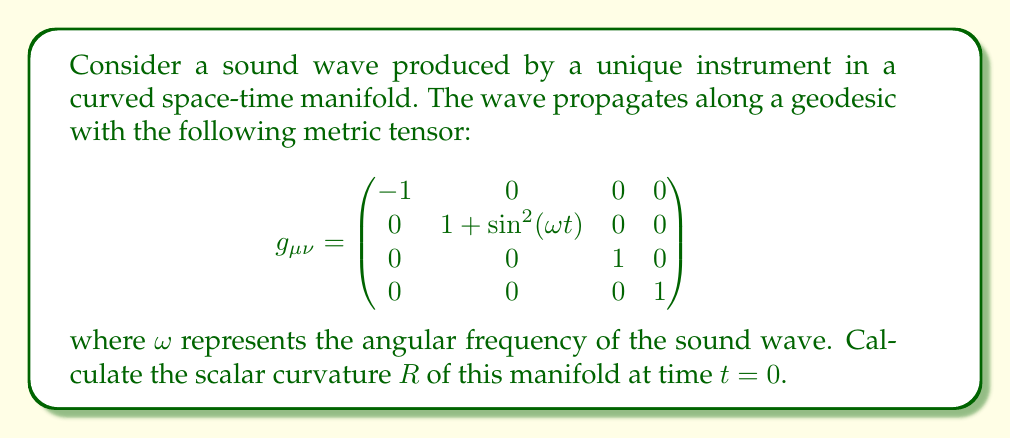Give your solution to this math problem. To calculate the scalar curvature of the manifold, we need to follow these steps:

1) First, we need to calculate the Christoffel symbols $\Gamma^{\mu}_{\nu\lambda}$ using the metric tensor:

   $$\Gamma^{\mu}_{\nu\lambda} = \frac{1}{2}g^{\mu\sigma}(\partial_\nu g_{\sigma\lambda} + \partial_\lambda g_{\sigma\nu} - \partial_\sigma g_{\nu\lambda})$$

2) The only non-zero partial derivatives of the metric tensor are:

   $$\partial_t g_{11} = 2\omega\sin(\omega t)\cos(\omega t)$$
   $$\partial_t g_{11}|_{t=0} = 0$$

3) This means that all Christoffel symbols are zero at $t=0$.

4) Next, we calculate the Riemann curvature tensor:

   $$R^\rho_{\sigma\mu\nu} = \partial_\mu \Gamma^\rho_{\nu\sigma} - \partial_\nu \Gamma^\rho_{\mu\sigma} + \Gamma^\rho_{\mu\lambda}\Gamma^\lambda_{\nu\sigma} - \Gamma^\rho_{\nu\lambda}\Gamma^\lambda_{\mu\sigma}$$

5) Since all Christoffel symbols are zero at $t=0$, the only non-zero components of the Riemann tensor will come from the partial derivatives of the Christoffel symbols.

6) The relevant non-zero component is:

   $$R^1_{010} = -R^1_{100} = \partial_t \Gamma^1_{00}|_{t=0} = \frac{1}{2}g^{11}\partial_t(\partial_t g_{11})|_{t=0} = \frac{1}{2} \cdot 1 \cdot 2\omega^2 = \omega^2$$

7) The Ricci tensor is the contraction of the Riemann tensor:

   $$R_{\mu\nu} = R^\lambda_{\mu\lambda\nu}$$

   The only non-zero component is $R_{00} = -\omega^2$.

8) Finally, the scalar curvature is the trace of the Ricci tensor:

   $$R = g^{\mu\nu}R_{\mu\nu} = g^{00}R_{00} = -1 \cdot (-\omega^2) = \omega^2$$

Therefore, the scalar curvature at $t=0$ is $\omega^2$.
Answer: The scalar curvature $R$ of the manifold at time $t=0$ is $\omega^2$, where $\omega$ is the angular frequency of the sound wave. 